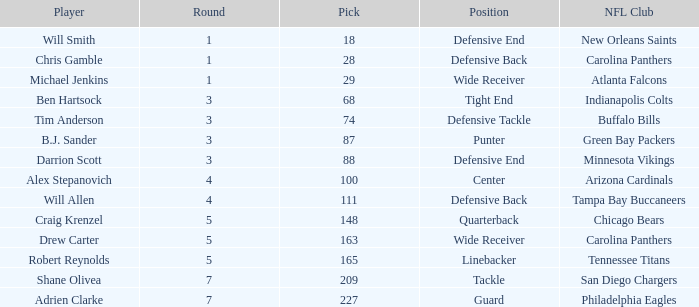What is the typical round number for player adrien clarke? 7.0. 